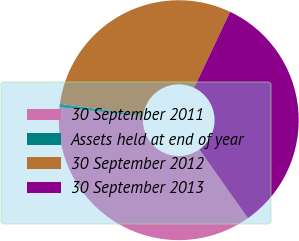<chart> <loc_0><loc_0><loc_500><loc_500><pie_chart><fcel>30 September 2011<fcel>Assets held at end of year<fcel>30 September 2012<fcel>30 September 2013<nl><fcel>36.5%<fcel>0.47%<fcel>29.86%<fcel>33.18%<nl></chart> 